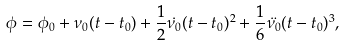Convert formula to latex. <formula><loc_0><loc_0><loc_500><loc_500>\phi = \phi _ { 0 } + \nu _ { 0 } ( t - t _ { 0 } ) + \frac { 1 } { 2 } \dot { \nu _ { 0 } } ( t - t _ { 0 } ) ^ { 2 } + \frac { 1 } { 6 } \ddot { \nu _ { 0 } } ( t - t _ { 0 } ) ^ { 3 } ,</formula> 